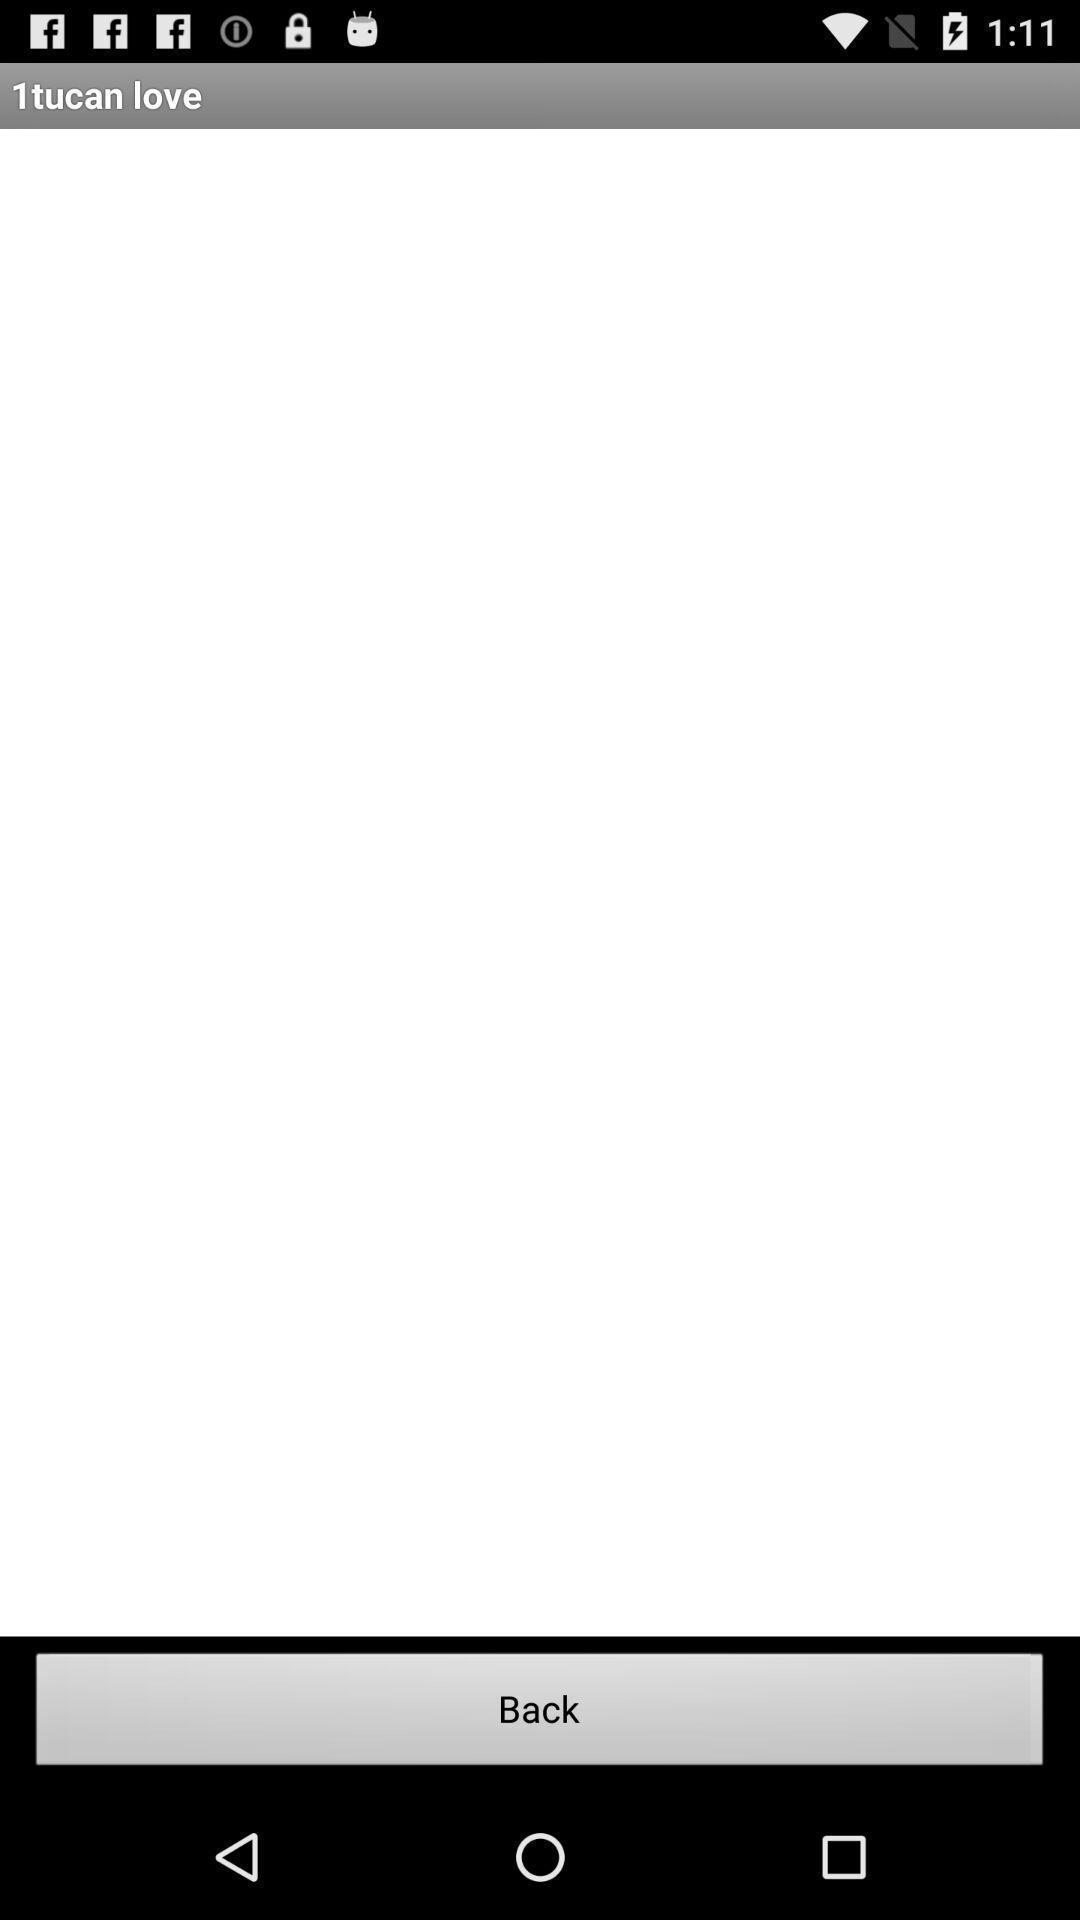Explain the elements present in this screenshot. Screen shows back option. 